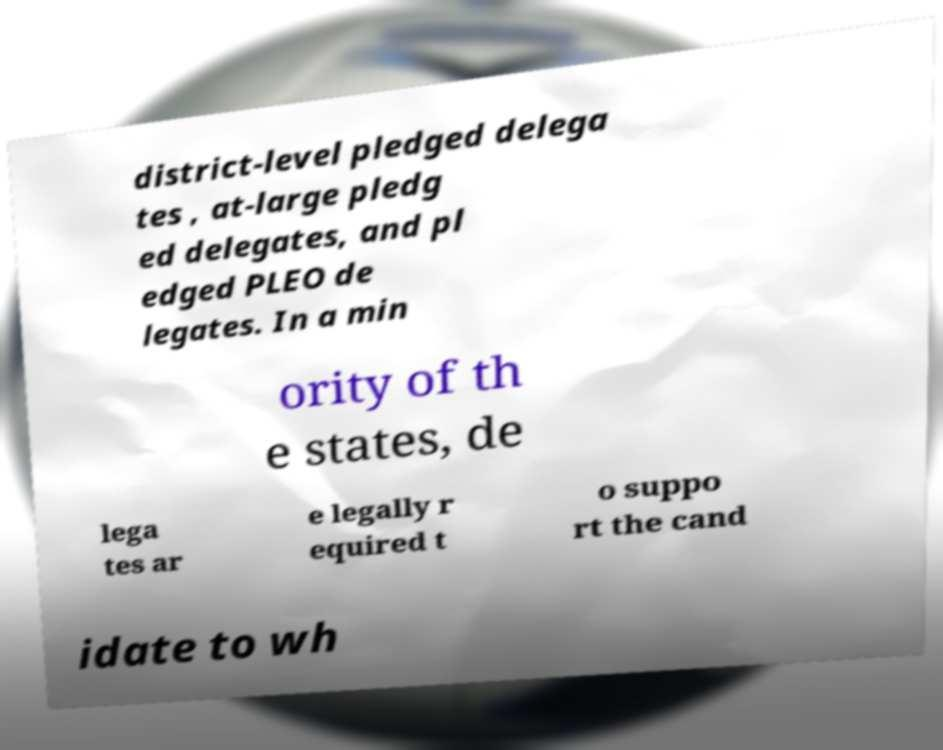Please identify and transcribe the text found in this image. district-level pledged delega tes , at-large pledg ed delegates, and pl edged PLEO de legates. In a min ority of th e states, de lega tes ar e legally r equired t o suppo rt the cand idate to wh 